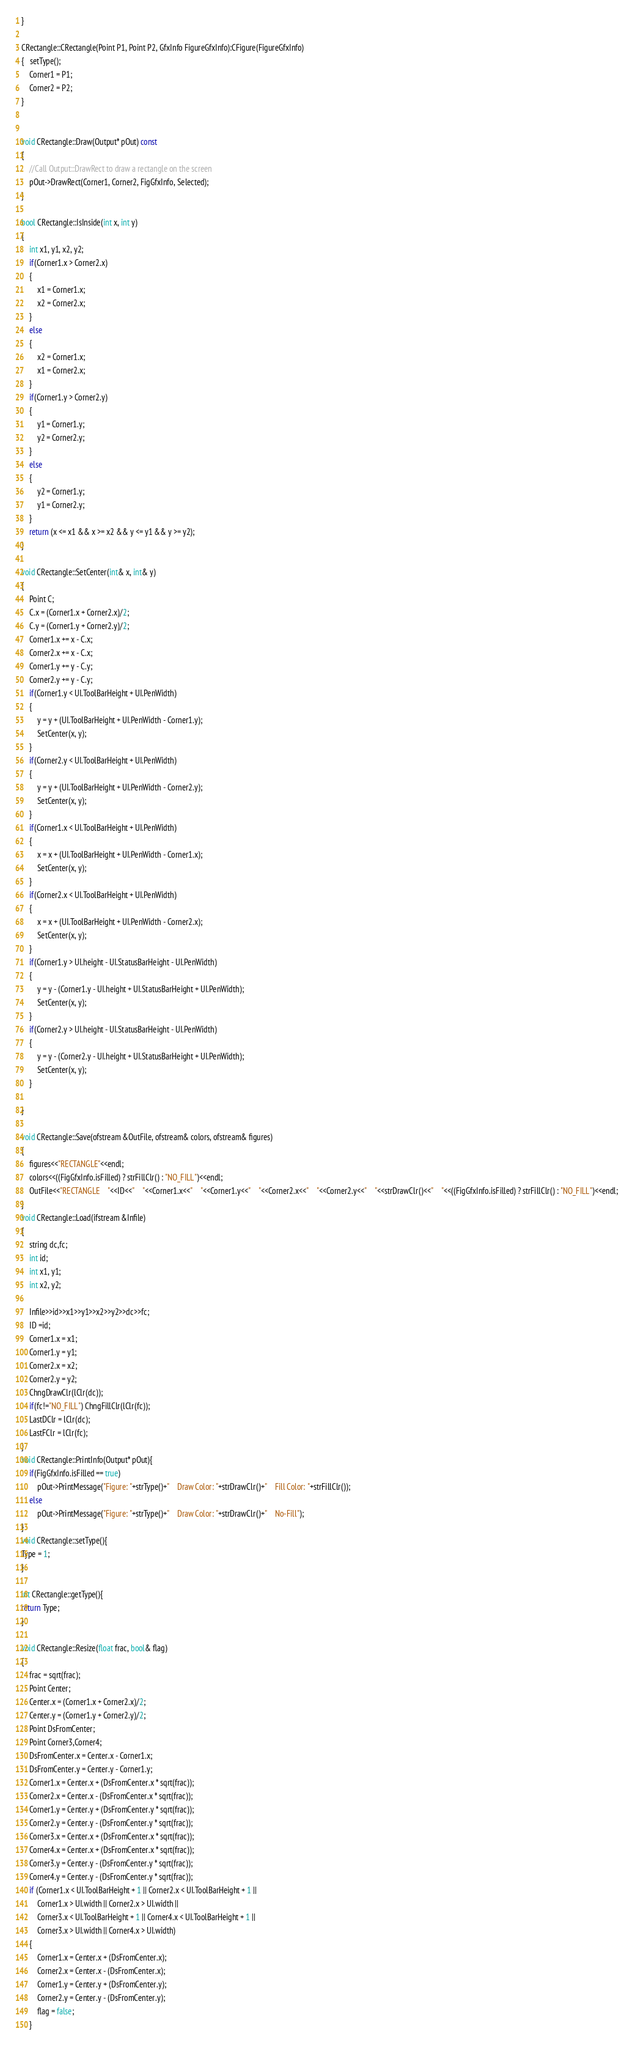<code> <loc_0><loc_0><loc_500><loc_500><_C++_>
}

CRectangle::CRectangle(Point P1, Point P2, GfxInfo FigureGfxInfo):CFigure(FigureGfxInfo)
{   setType();
	Corner1 = P1;
	Corner2 = P2;
}
	

void CRectangle::Draw(Output* pOut) const
{
	//Call Output::DrawRect to draw a rectangle on the screen	
	pOut->DrawRect(Corner1, Corner2, FigGfxInfo, Selected);
}

bool CRectangle::IsInside(int x, int y)
{
	int x1, y1, x2, y2;
	if(Corner1.x > Corner2.x)
	{
		x1 = Corner1.x;
		x2 = Corner2.x;
	}
	else
	{
		x2 = Corner1.x;
		x1 = Corner2.x;
	}
	if(Corner1.y > Corner2.y)
	{
		y1 = Corner1.y;
		y2 = Corner2.y;
	}
	else
	{
		y2 = Corner1.y;
		y1 = Corner2.y;
	}
	return (x <= x1 && x >= x2 && y <= y1 && y >= y2);
}

void CRectangle::SetCenter(int& x, int& y)
{
	Point C;
	C.x = (Corner1.x + Corner2.x)/2;
	C.y = (Corner1.y + Corner2.y)/2;
	Corner1.x += x - C.x;
	Corner2.x += x - C.x;
	Corner1.y += y - C.y;
	Corner2.y += y - C.y;
	if(Corner1.y < UI.ToolBarHeight + UI.PenWidth)
	{
		y = y + (UI.ToolBarHeight + UI.PenWidth - Corner1.y);
		SetCenter(x, y);
	}
	if(Corner2.y < UI.ToolBarHeight + UI.PenWidth)
	{
		y = y + (UI.ToolBarHeight + UI.PenWidth - Corner2.y);
		SetCenter(x, y);
	}
	if(Corner1.x < UI.ToolBarHeight + UI.PenWidth)
	{
		x = x + (UI.ToolBarHeight + UI.PenWidth - Corner1.x);
		SetCenter(x, y);
	}
	if(Corner2.x < UI.ToolBarHeight + UI.PenWidth)
	{
		x = x + (UI.ToolBarHeight + UI.PenWidth - Corner2.x);
		SetCenter(x, y);
	}
	if(Corner1.y > UI.height - UI.StatusBarHeight - UI.PenWidth)
	{
		y = y - (Corner1.y - UI.height + UI.StatusBarHeight + UI.PenWidth);
		SetCenter(x, y);
	}
	if(Corner2.y > UI.height - UI.StatusBarHeight - UI.PenWidth)
	{
		y = y - (Corner2.y - UI.height + UI.StatusBarHeight + UI.PenWidth);
		SetCenter(x, y);
	}

}

void CRectangle::Save(ofstream &OutFile, ofstream& colors, ofstream& figures)
{
	figures<<"RECTANGLE"<<endl;
	colors<<((FigGfxInfo.isFilled) ? strFillClr() : "NO_FILL")<<endl;
	OutFile<<"RECTANGLE    "<<ID<<"    "<<Corner1.x<<"    "<<Corner1.y<<"    "<<Corner2.x<<"    "<<Corner2.y<<"    "<<strDrawClr()<<"    "<<((FigGfxInfo.isFilled) ? strFillClr() : "NO_FILL")<<endl; 
}
void CRectangle::Load(ifstream &Infile)
{
	string dc,fc;
	int id;
	int x1, y1;
	int x2, y2;
	
	Infile>>id>>x1>>y1>>x2>>y2>>dc>>fc;
    ID =id;
	Corner1.x = x1;
    Corner1.y = y1;
	Corner2.x = x2;
	Corner2.y = y2;
	ChngDrawClr(lClr(dc));
	if(fc!="NO_FILL") ChngFillClr(lClr(fc));
	LastDClr = lClr(dc);
	LastFClr = lClr(fc);
}
void CRectangle::PrintInfo(Output* pOut){
	if(FigGfxInfo.isFilled == true)
		pOut->PrintMessage("Figure: "+strType()+"    Draw Color: "+strDrawClr()+"    Fill Color: "+strFillClr());
	else
        pOut->PrintMessage("Figure: "+strType()+"    Draw Color: "+strDrawClr()+"    No-Fill");
}
void CRectangle::setType(){
Type = 1;
}

int CRectangle::getType(){
return Type;
}

void CRectangle::Resize(float frac, bool& flag)
{
	frac = sqrt(frac);
	Point Center;
	Center.x = (Corner1.x + Corner2.x)/2;
	Center.y = (Corner1.y + Corner2.y)/2;
	Point DsFromCenter;
	Point Corner3,Corner4;
	DsFromCenter.x = Center.x - Corner1.x;
	DsFromCenter.y = Center.y - Corner1.y;
	Corner1.x = Center.x + (DsFromCenter.x * sqrt(frac));
	Corner2.x = Center.x - (DsFromCenter.x * sqrt(frac));
	Corner1.y = Center.y + (DsFromCenter.y * sqrt(frac));
	Corner2.y = Center.y - (DsFromCenter.y * sqrt(frac));
	Corner3.x = Center.x + (DsFromCenter.x * sqrt(frac));
	Corner4.x = Center.x + (DsFromCenter.x * sqrt(frac));
	Corner3.y = Center.y - (DsFromCenter.y * sqrt(frac));
	Corner4.y = Center.y - (DsFromCenter.y * sqrt(frac));
	if (Corner1.x < UI.ToolBarHeight + 1 || Corner2.x < UI.ToolBarHeight + 1 ||
		Corner1.x > UI.width || Corner2.x > UI.width || 
		Corner3.x < UI.ToolBarHeight + 1 || Corner4.x < UI.ToolBarHeight + 1 ||
		Corner3.x > UI.width || Corner4.x > UI.width)
	{
		Corner1.x = Center.x + (DsFromCenter.x);
		Corner2.x = Center.x - (DsFromCenter.x);
		Corner1.y = Center.y + (DsFromCenter.y);
		Corner2.y = Center.y - (DsFromCenter.y);
		flag = false;
	}</code> 